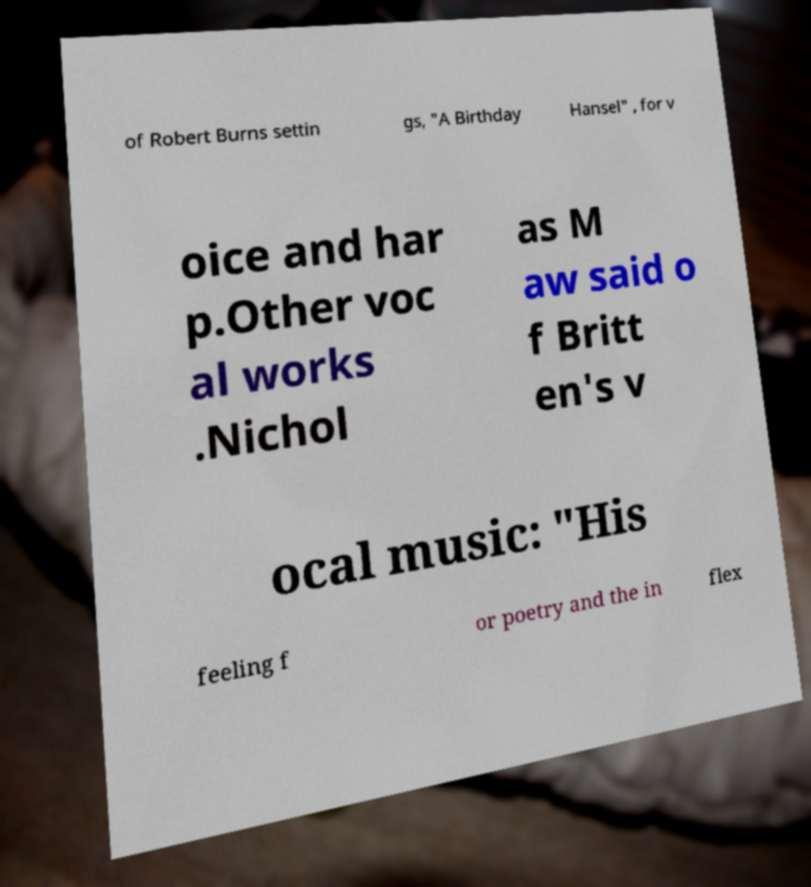Could you assist in decoding the text presented in this image and type it out clearly? of Robert Burns settin gs, "A Birthday Hansel" , for v oice and har p.Other voc al works .Nichol as M aw said o f Britt en's v ocal music: "His feeling f or poetry and the in flex 